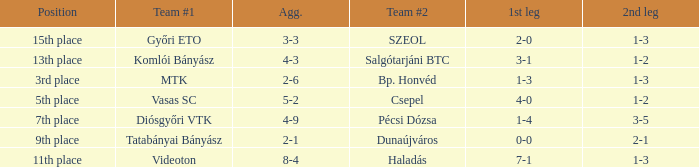What is the 1st leg with a 4-3 agg.? 3-1. 